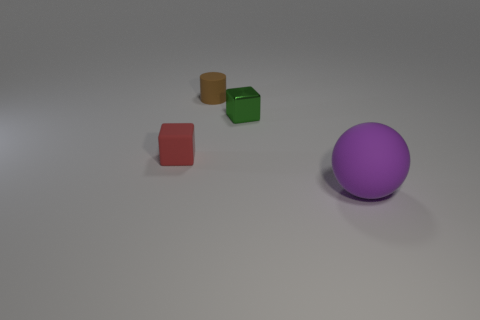Is there any other thing that is the same size as the purple rubber object?
Offer a very short reply. No. How many big brown cylinders are made of the same material as the small red block?
Offer a very short reply. 0. Is the number of balls less than the number of rubber things?
Offer a very short reply. Yes. Does the big sphere on the right side of the green block have the same material as the tiny brown object?
Offer a terse response. Yes. What number of blocks are either large purple things or small red things?
Provide a succinct answer. 1. The thing that is behind the large purple rubber object and to the right of the tiny brown cylinder has what shape?
Give a very brief answer. Cube. There is a small block that is on the right side of the tiny rubber thing behind the block to the left of the small metal block; what color is it?
Provide a short and direct response. Green. Is the number of small blocks behind the red cube less than the number of objects?
Offer a very short reply. Yes. Is the shape of the brown thing behind the rubber cube the same as the small matte thing in front of the small metallic cube?
Offer a terse response. No. What number of things are things that are on the right side of the brown thing or brown matte things?
Offer a very short reply. 3. 